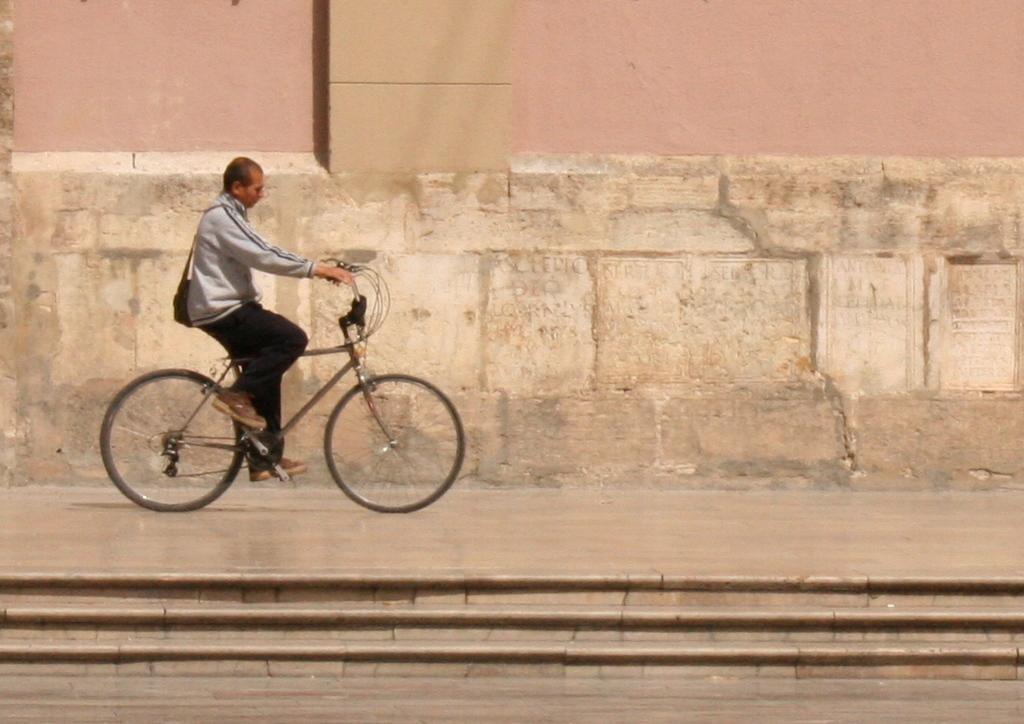Who is present in the image? There is a man in the image. What is the man doing in the image? The man is sitting on a bicycle. What architectural feature can be seen in the image? There are stairs in the image. What type of cats can be seen playing with a glass object in the image? There are no cats or glass objects present in the image; it features a man sitting on a bicycle and stairs. 